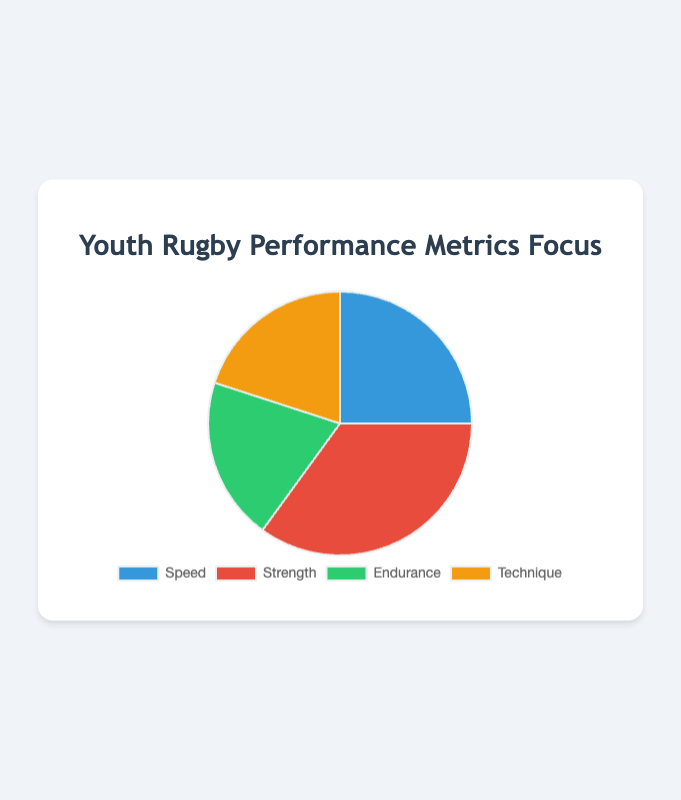What's the percentage focus on strength and technique combined? To find the combined focus on strength and technique, add their respective percentages. Strength is 35% and technique is 20%. So, 35% + 20% = 55%.
Answer: 55% Which performance metric has the highest focus? The performance metric with the highest focus is the one with the largest percentage. Here, strength has the highest percentage at 35%.
Answer: Strength Is the focus on speed equal to the focus on endurance? To determine if the focus is equal, compare the percentages. Speed is 25% and endurance is 20%. Since 25% is not equal to 20%, they are not equal.
Answer: No How much more focus is given to strength compared to endurance? To find how much more focus is given to strength compared to endurance, subtract the percentage of endurance from the percentage of strength. Strength is 35% and endurance is 20%, so 35% - 20% = 15%.
Answer: 15% What is the average focus on speed and endurance? To find the average, add the percentages of speed and endurance and then divide by 2. Speed is 25% and endurance is 20%, so (25% + 20%) / 2 = 22.5%.
Answer: 22.5% Which performance metrics have an equal focus? To determine this, compare the percentages. Both endurance and technique have a focus of 20%.
Answer: Endurance and Technique What is the difference in focus between the highest and lowest metrics? To find the difference between the highest and lowest focus, subtract the lowest percentage from the highest percentage. The highest is strength at 35% and the lowest is endurance (or technique) at 20%, so 35% - 20% = 15%.
Answer: 15% What is the focus percentage on metrics other than strength? To find the focus percentage on metrics other than strength, subtract the strength focus from 100%. Strength is 35%, so 100% - 35% = 65%.
Answer: 65% Which metric is represented by the color blue? According to the pie chart design data, the color blue corresponds to the first metric, which is speed.
Answer: Speed Out of technique and speed, which has a lower focus percentage? To determine this, compare the percentages for technique and speed: technique has 20% and speed has 25%. Thus, technique has a lower focus percentage.
Answer: Technique 